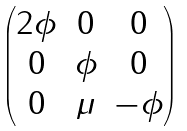Convert formula to latex. <formula><loc_0><loc_0><loc_500><loc_500>\begin{pmatrix} 2 \phi & 0 & 0 \\ 0 & \phi & 0 \\ 0 & \mu & - \phi \end{pmatrix}</formula> 